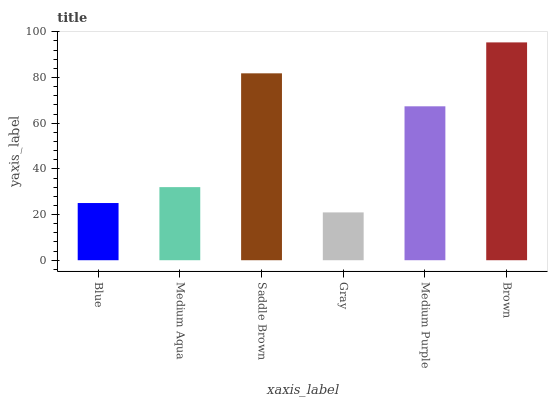Is Gray the minimum?
Answer yes or no. Yes. Is Brown the maximum?
Answer yes or no. Yes. Is Medium Aqua the minimum?
Answer yes or no. No. Is Medium Aqua the maximum?
Answer yes or no. No. Is Medium Aqua greater than Blue?
Answer yes or no. Yes. Is Blue less than Medium Aqua?
Answer yes or no. Yes. Is Blue greater than Medium Aqua?
Answer yes or no. No. Is Medium Aqua less than Blue?
Answer yes or no. No. Is Medium Purple the high median?
Answer yes or no. Yes. Is Medium Aqua the low median?
Answer yes or no. Yes. Is Medium Aqua the high median?
Answer yes or no. No. Is Gray the low median?
Answer yes or no. No. 